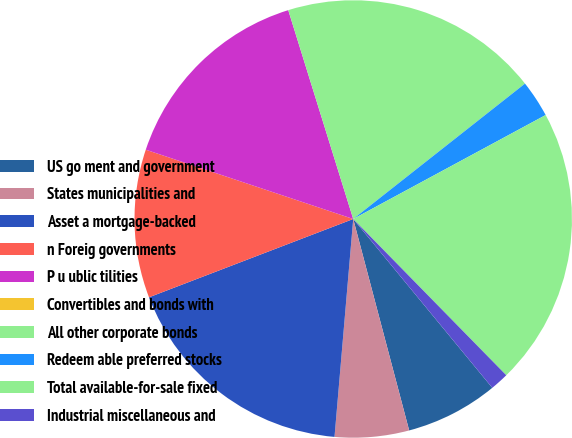Convert chart to OTSL. <chart><loc_0><loc_0><loc_500><loc_500><pie_chart><fcel>US go ment and government<fcel>States municipalities and<fcel>Asset a mortgage-backed<fcel>n Foreig governments<fcel>P u ublic tilities<fcel>Convertibles and bonds with<fcel>All other corporate bonds<fcel>Redeem able preferred stocks<fcel>Total available-for-sale fixed<fcel>Industrial miscellaneous and<nl><fcel>6.85%<fcel>5.48%<fcel>17.81%<fcel>10.96%<fcel>15.07%<fcel>0.0%<fcel>19.18%<fcel>2.74%<fcel>20.55%<fcel>1.37%<nl></chart> 